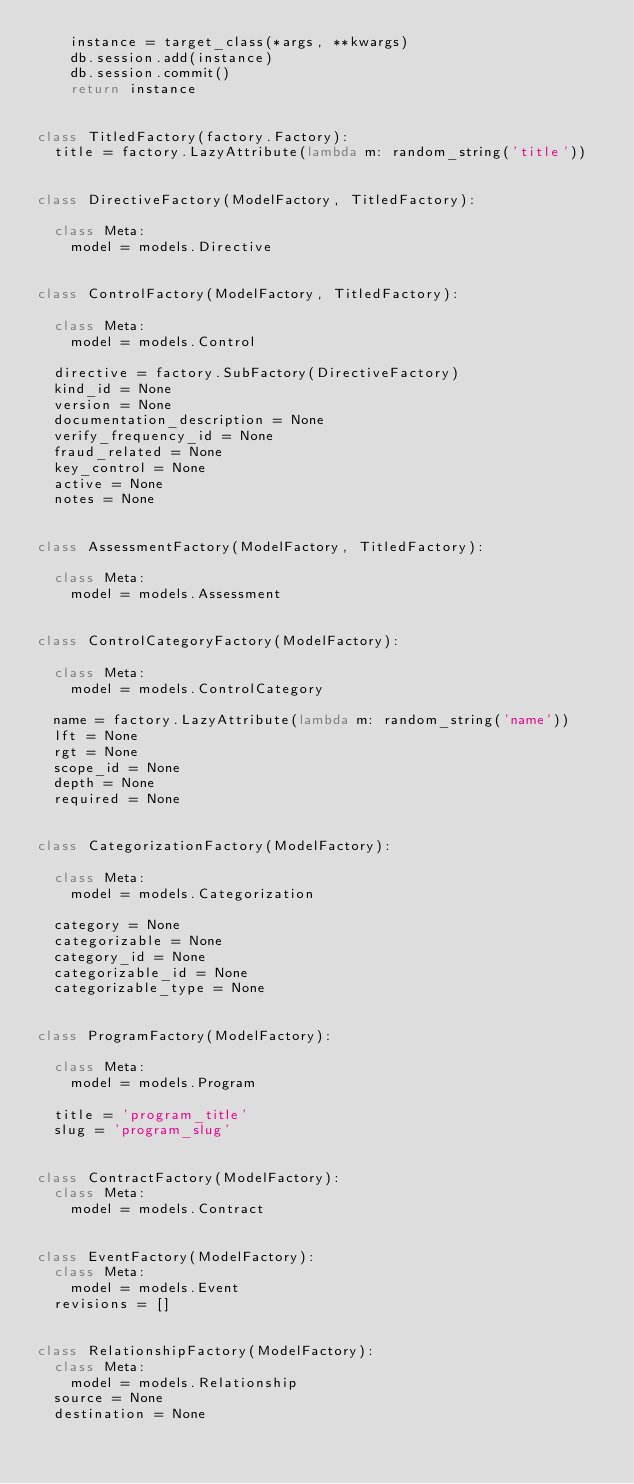<code> <loc_0><loc_0><loc_500><loc_500><_Python_>    instance = target_class(*args, **kwargs)
    db.session.add(instance)
    db.session.commit()
    return instance


class TitledFactory(factory.Factory):
  title = factory.LazyAttribute(lambda m: random_string('title'))


class DirectiveFactory(ModelFactory, TitledFactory):

  class Meta:
    model = models.Directive


class ControlFactory(ModelFactory, TitledFactory):

  class Meta:
    model = models.Control

  directive = factory.SubFactory(DirectiveFactory)
  kind_id = None
  version = None
  documentation_description = None
  verify_frequency_id = None
  fraud_related = None
  key_control = None
  active = None
  notes = None


class AssessmentFactory(ModelFactory, TitledFactory):

  class Meta:
    model = models.Assessment


class ControlCategoryFactory(ModelFactory):

  class Meta:
    model = models.ControlCategory

  name = factory.LazyAttribute(lambda m: random_string('name'))
  lft = None
  rgt = None
  scope_id = None
  depth = None
  required = None


class CategorizationFactory(ModelFactory):

  class Meta:
    model = models.Categorization

  category = None
  categorizable = None
  category_id = None
  categorizable_id = None
  categorizable_type = None


class ProgramFactory(ModelFactory):

  class Meta:
    model = models.Program

  title = 'program_title'
  slug = 'program_slug'


class ContractFactory(ModelFactory):
  class Meta:
    model = models.Contract


class EventFactory(ModelFactory):
  class Meta:
    model = models.Event
  revisions = []


class RelationshipFactory(ModelFactory):
  class Meta:
    model = models.Relationship
  source = None
  destination = None
</code> 